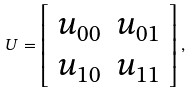Convert formula to latex. <formula><loc_0><loc_0><loc_500><loc_500>U = \left [ \begin{array} { c c } u _ { 0 0 } & u _ { 0 1 } \\ u _ { 1 0 } & u _ { 1 1 } \end{array} \right ] ,</formula> 